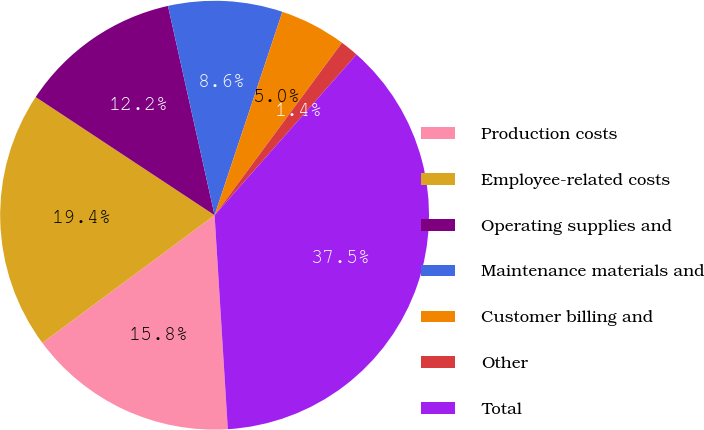<chart> <loc_0><loc_0><loc_500><loc_500><pie_chart><fcel>Production costs<fcel>Employee-related costs<fcel>Operating supplies and<fcel>Maintenance materials and<fcel>Customer billing and<fcel>Other<fcel>Total<nl><fcel>15.83%<fcel>19.44%<fcel>12.22%<fcel>8.61%<fcel>5.0%<fcel>1.39%<fcel>37.5%<nl></chart> 